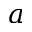<formula> <loc_0><loc_0><loc_500><loc_500>a</formula> 